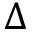<formula> <loc_0><loc_0><loc_500><loc_500>\Delta</formula> 